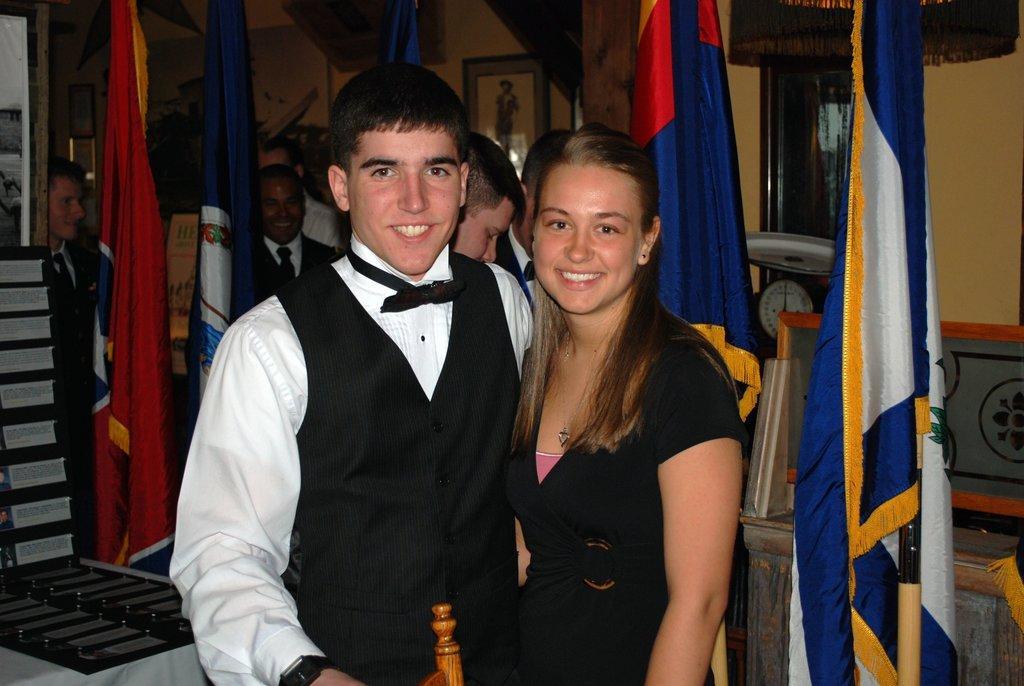Could you give a brief overview of what you see in this image? In this image we can see a man and a woman standing and smiling. We can also see a few people. Image also consists of flags, clock, an object on the left which is on the table which is covered with the white cloth. We can also see the frames attached to the plain wall. 